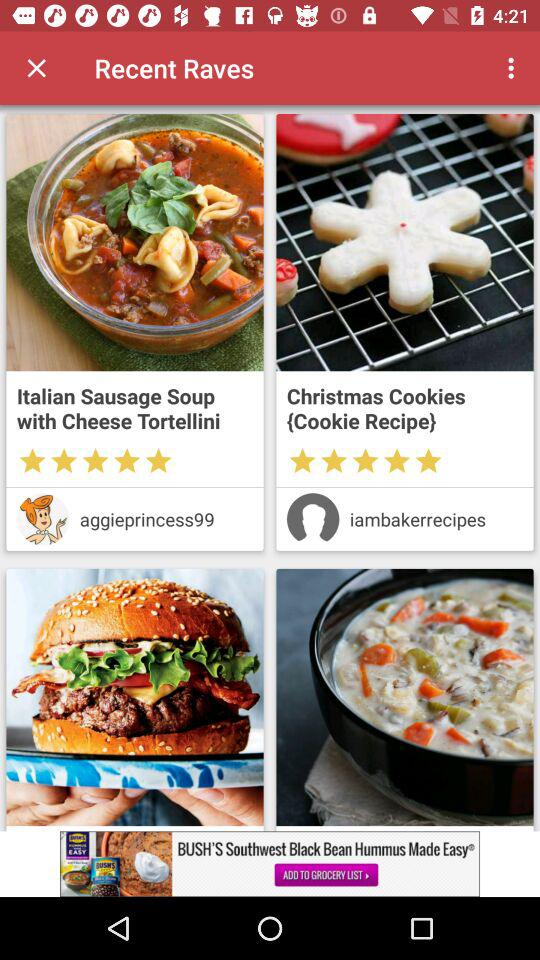What are the names of the dishes? The names of the dishes are "Italian Sausage Soup with Cheese Tortellini" and "Christmas Cookies {Cookie Recipe}". 